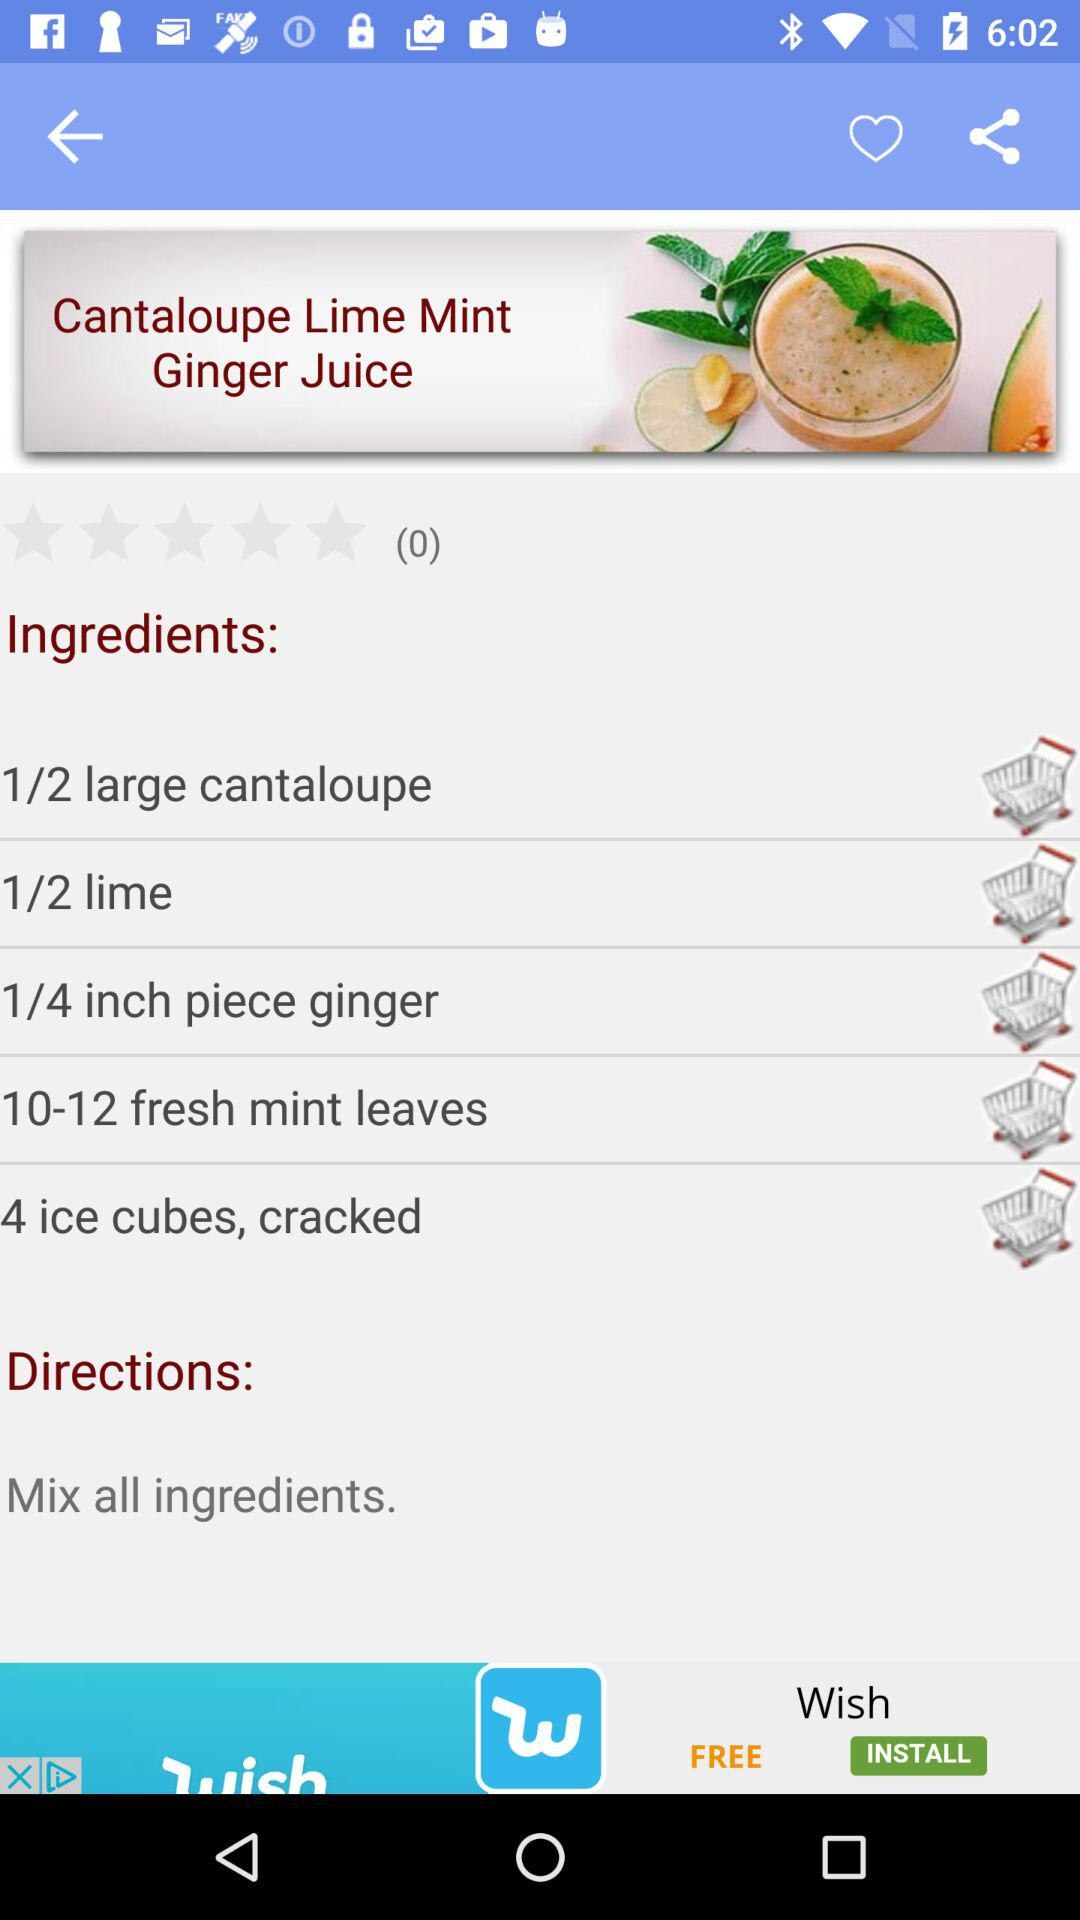What are the ingredients of the Cantaloupe Lime Mint Ginger Juice? The ingredients are "1/2 large cantaloupe", "1/2 lime", "1/4 inch piece ginger", "10-12 fresh mint leaves" and "4 ice cubes, cracked". 